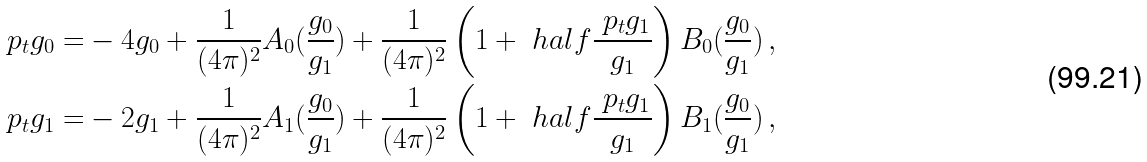<formula> <loc_0><loc_0><loc_500><loc_500>\ p _ { t } g _ { 0 } = & - 4 g _ { 0 } + \frac { 1 } { ( 4 \pi ) ^ { 2 } } A _ { 0 } ( \frac { g _ { 0 } } { g _ { 1 } } ) + \frac { 1 } { ( 4 \pi ) ^ { 2 } } \left ( 1 + \ h a l f \frac { \ p _ { t } g _ { 1 } } { g _ { 1 } } \right ) B _ { 0 } ( \frac { g _ { 0 } } { g _ { 1 } } ) \, , \\ \ p _ { t } g _ { 1 } = & - 2 g _ { 1 } + \frac { 1 } { ( 4 \pi ) ^ { 2 } } A _ { 1 } ( \frac { g _ { 0 } } { g _ { 1 } } ) + \frac { 1 } { ( 4 \pi ) ^ { 2 } } \left ( 1 + \ h a l f \frac { \ p _ { t } g _ { 1 } } { g _ { 1 } } \right ) B _ { 1 } ( \frac { g _ { 0 } } { g _ { 1 } } ) \, ,</formula> 